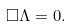<formula> <loc_0><loc_0><loc_500><loc_500>\Box \Lambda = 0 .</formula> 